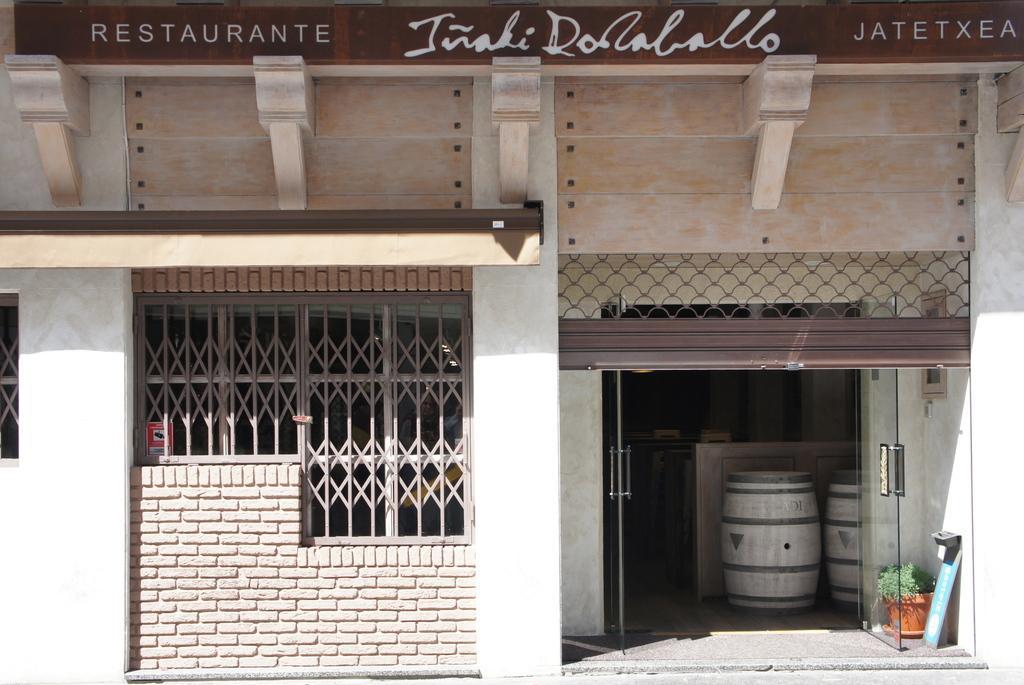How would you summarize this image in a sentence or two? This is a picture of a restaurant. In the foreground of the picture there are shutter, grills, window, brick wall and a wall. At the top there is hoarding. In the background there are drums and some other objects. On the right there is a flower pot. 